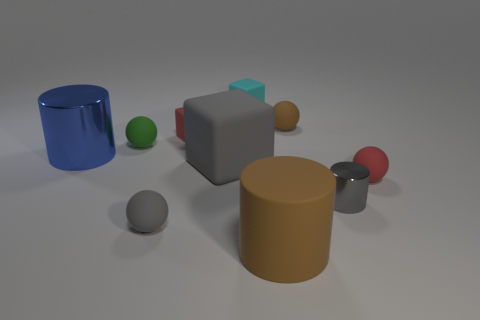Subtract all balls. How many objects are left? 6 Subtract 0 purple blocks. How many objects are left? 10 Subtract all blue things. Subtract all small brown balls. How many objects are left? 8 Add 8 tiny brown rubber balls. How many tiny brown rubber balls are left? 9 Add 4 cyan objects. How many cyan objects exist? 5 